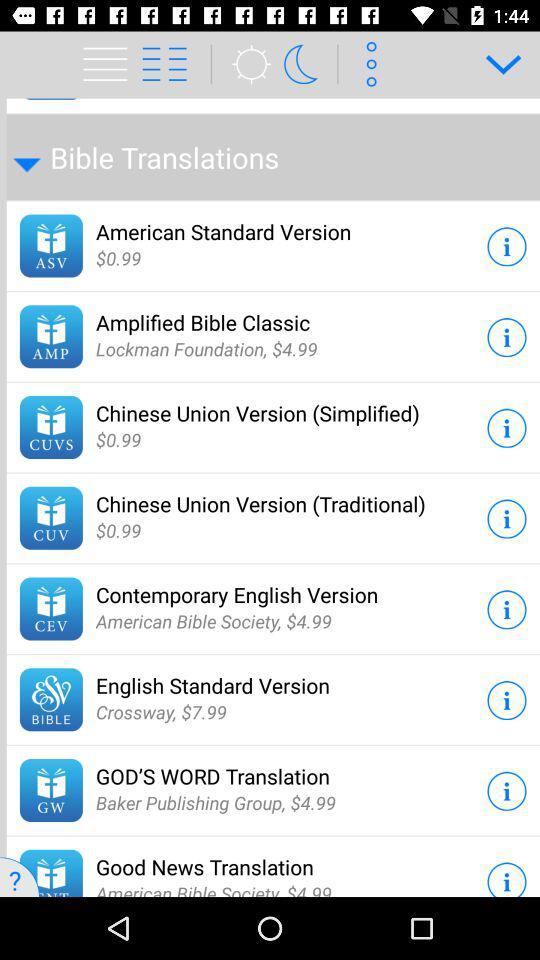Who published the God's Word Translation? The God's Word Translation is published by the Baker Publishing Group. 